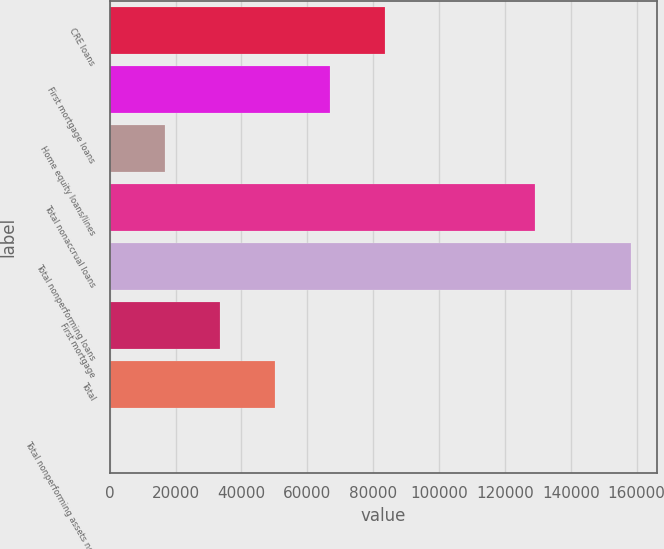<chart> <loc_0><loc_0><loc_500><loc_500><bar_chart><fcel>CRE loans<fcel>First mortgage loans<fcel>Home equity loans/lines<fcel>Total nonaccrual loans<fcel>Total nonperforming loans<fcel>First mortgage<fcel>Total<fcel>Total nonperforming assets net<nl><fcel>83537.6<fcel>66830.5<fcel>16709.2<fcel>129058<fcel>158382<fcel>33416.3<fcel>50123.4<fcel>2.1<nl></chart> 